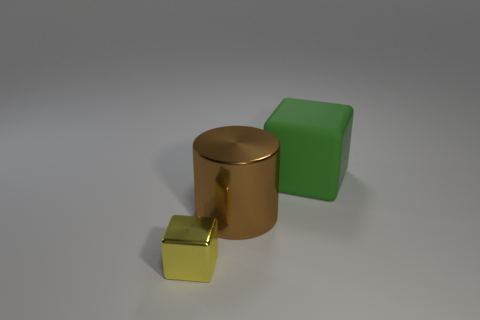How do the shapes of the objects relate to each other? The shapes in the image - a cylinder, cube, and another smaller cube - demonstrate the fundamental geometric forms of 3D modeling. Their simplicity and the way they are positioned allow for a study of form and spatial relationships. Each shape's distinct edges and surfaces interact with the light differently, creating a diverse range of highlights and shadows which contribute to the perception of their volume and texture. 